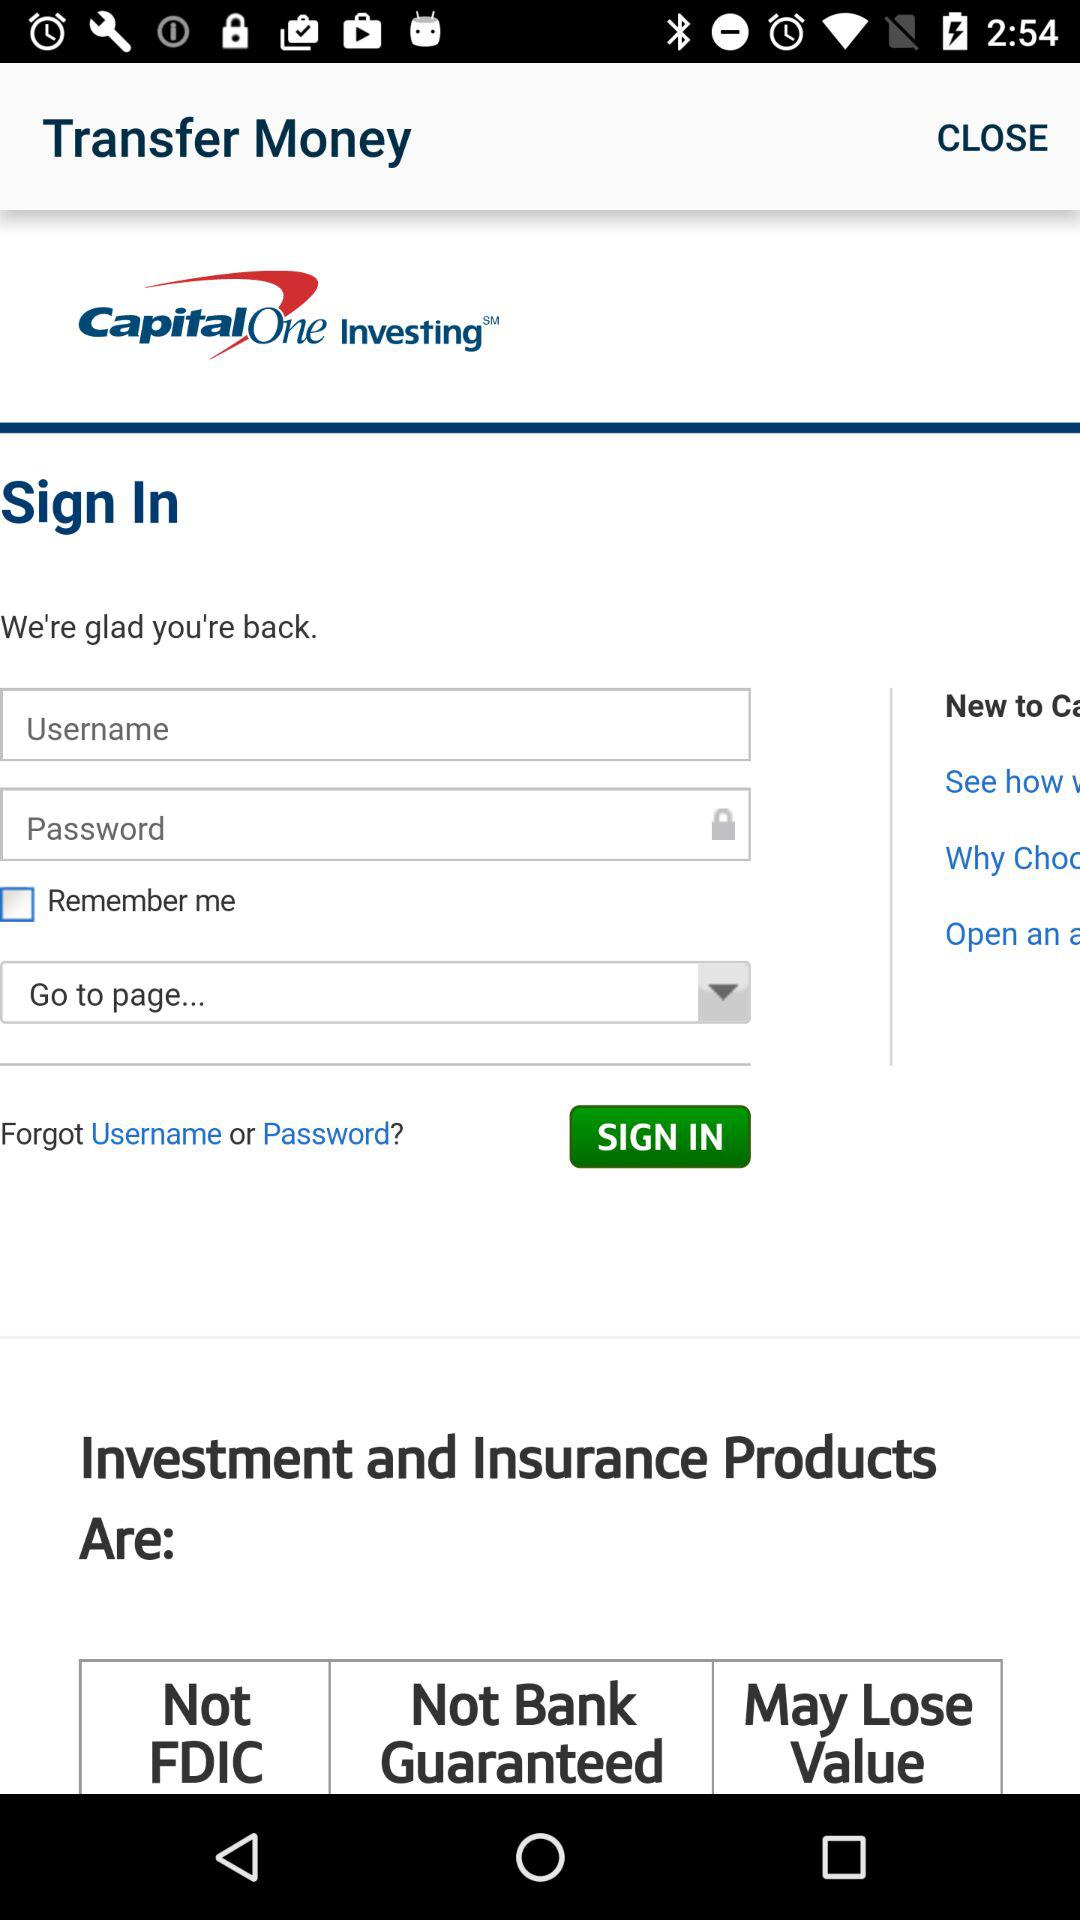What is the status of "Remember me"? The status of "Remember me" is "off". 